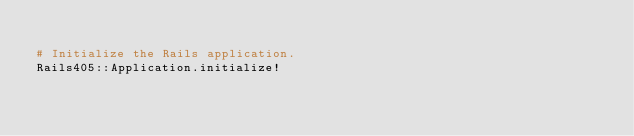<code> <loc_0><loc_0><loc_500><loc_500><_Ruby_>
# Initialize the Rails application.
Rails405::Application.initialize!
</code> 